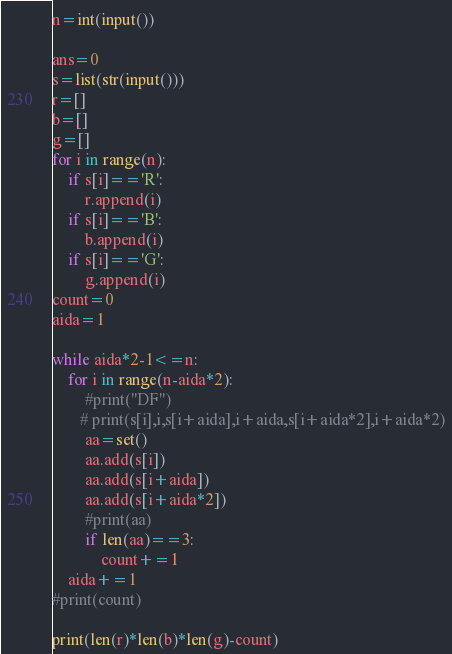<code> <loc_0><loc_0><loc_500><loc_500><_Python_>n=int(input())

ans=0
s=list(str(input()))
r=[]
b=[]
g=[]
for i in range(n):
    if s[i]=='R':
        r.append(i)
    if s[i]=='B':
        b.append(i)
    if s[i]=='G':
        g.append(i)
count=0
aida=1

while aida*2-1<=n:
    for i in range(n-aida*2):
        #print("DF")
       # print(s[i],i,s[i+aida],i+aida,s[i+aida*2],i+aida*2)
        aa=set()
        aa.add(s[i])
        aa.add(s[i+aida])
        aa.add(s[i+aida*2])
        #print(aa)
        if len(aa)==3:
            count+=1
    aida+=1
#print(count)

print(len(r)*len(b)*len(g)-count)</code> 